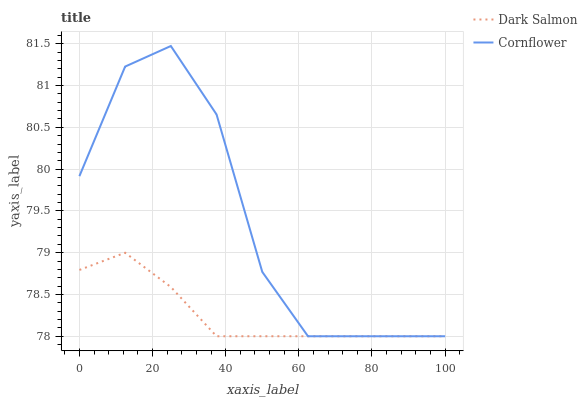Does Dark Salmon have the minimum area under the curve?
Answer yes or no. Yes. Does Cornflower have the maximum area under the curve?
Answer yes or no. Yes. Does Dark Salmon have the maximum area under the curve?
Answer yes or no. No. Is Dark Salmon the smoothest?
Answer yes or no. Yes. Is Cornflower the roughest?
Answer yes or no. Yes. Is Dark Salmon the roughest?
Answer yes or no. No. Does Cornflower have the lowest value?
Answer yes or no. Yes. Does Cornflower have the highest value?
Answer yes or no. Yes. Does Dark Salmon have the highest value?
Answer yes or no. No. Does Dark Salmon intersect Cornflower?
Answer yes or no. Yes. Is Dark Salmon less than Cornflower?
Answer yes or no. No. Is Dark Salmon greater than Cornflower?
Answer yes or no. No. 